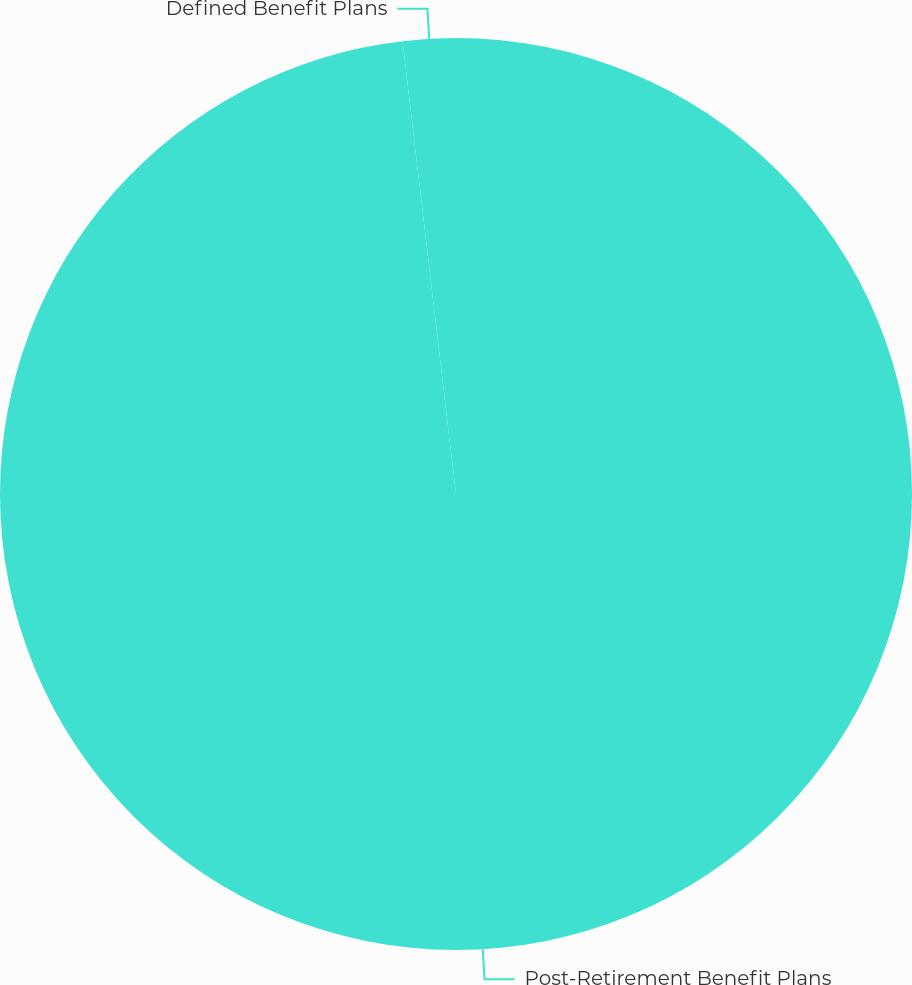Convert chart. <chart><loc_0><loc_0><loc_500><loc_500><pie_chart><fcel>Post-Retirement Benefit Plans<fcel>Defined Benefit Plans<nl><fcel>98.13%<fcel>1.87%<nl></chart> 